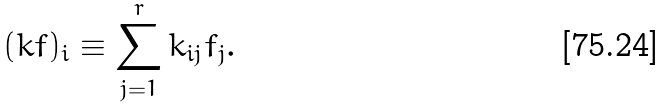Convert formula to latex. <formula><loc_0><loc_0><loc_500><loc_500>( k f ) _ { i } \equiv \sum _ { j = 1 } ^ { r } k _ { i j } f _ { j } .</formula> 